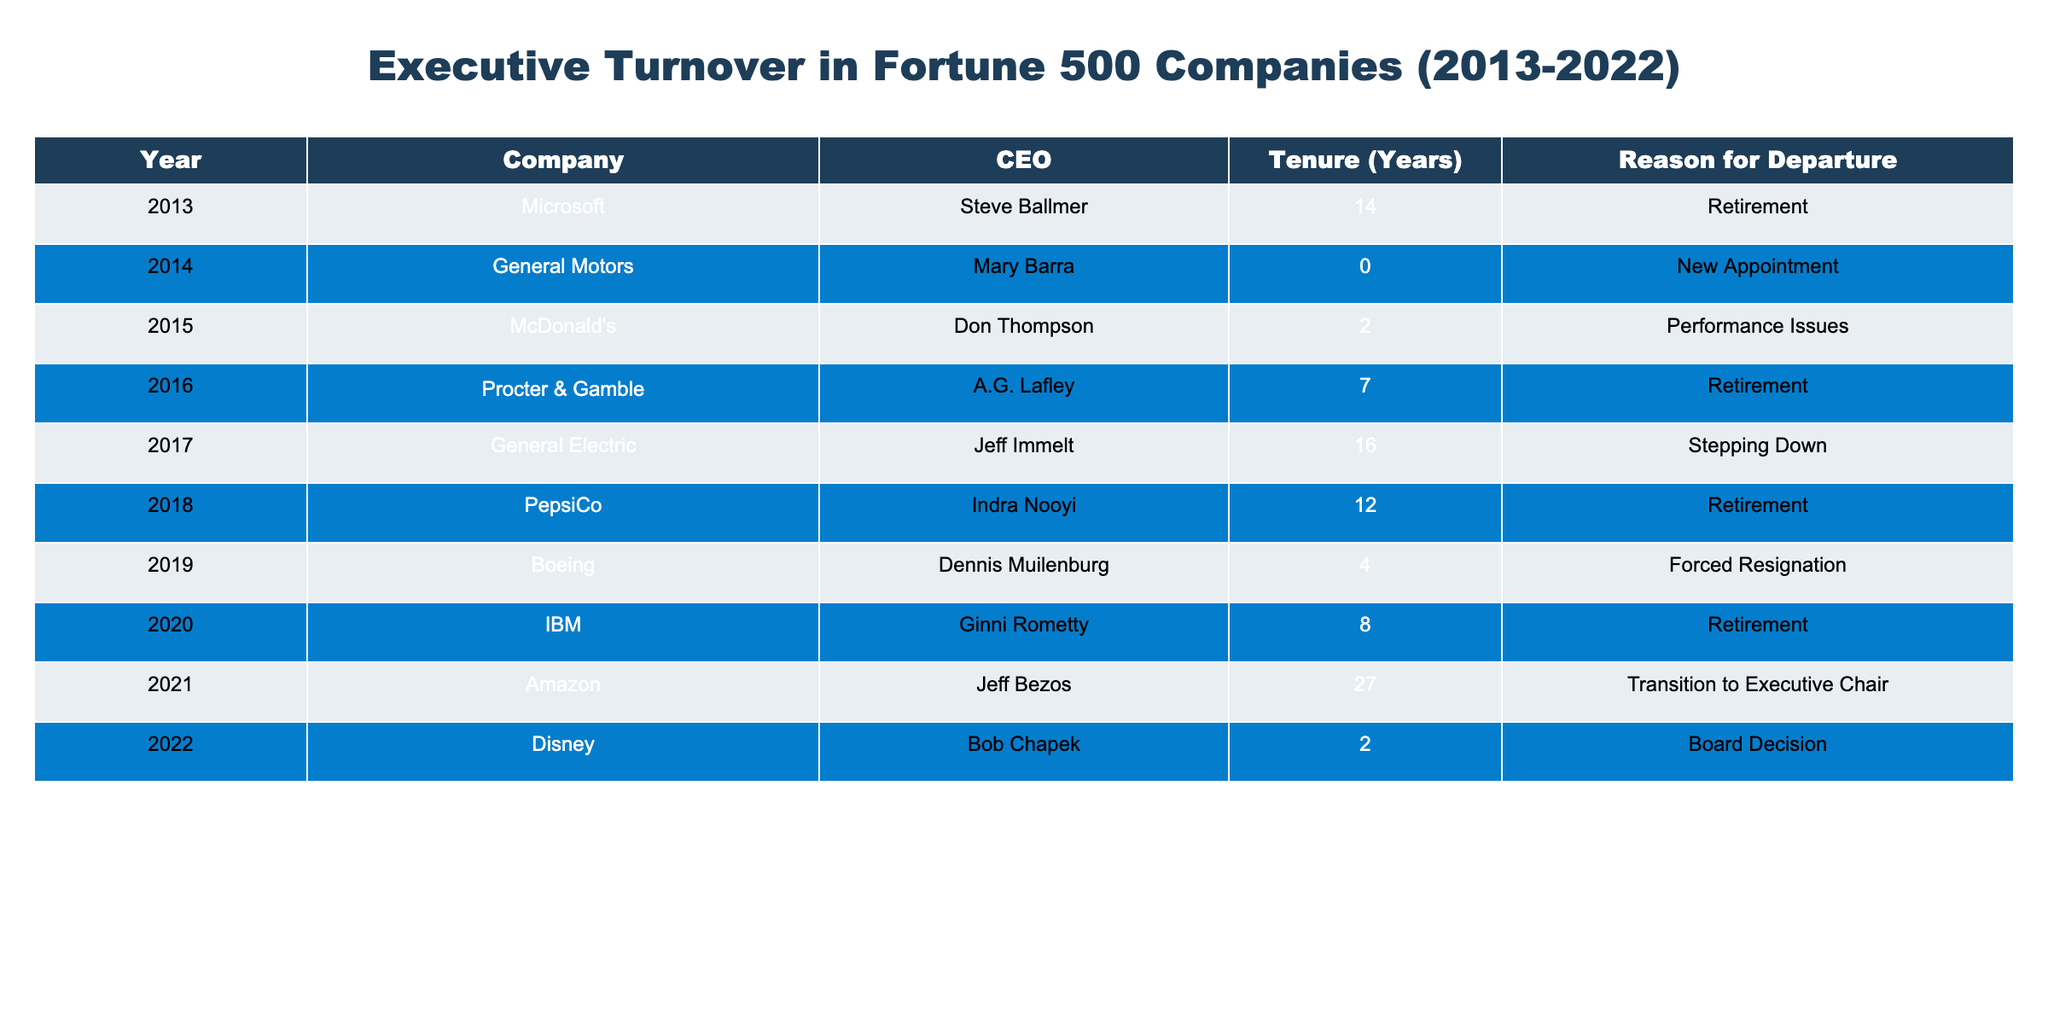What year did Steve Ballmer retire from Microsoft? According to the table, Steve Ballmer retired in 2013.
Answer: 2013 How long did Indra Nooyi serve as CEO of PepsiCo? Indra Nooyi served as CEO for 12 years, as indicated in the tenure column.
Answer: 12 years What was the common reason for CEO departures in this table over the years? By reviewing the reasons for departure, "Retirement" appears multiple times, indicating it is a common reason.
Answer: Yes Which company had the longest-serving CEO based on this table? Jeff Bezos served as CEO of Amazon for 27 years, which is the highest tenure listed in the table.
Answer: Amazon What is the average tenure of the CEOs listed in the table? To find the average, sum the tenures (14 + 0 + 2 + 7 + 16 + 12 + 4 + 8 + 27 + 2 = 92) and divide by the number of CEOs (10). Thus, 92 / 10 = 9.2 years.
Answer: 9.2 years Did any CEO leave due to "Performance Issues"? Yes, Don Thompson left McDonald's due to performance issues.
Answer: Yes What is the difference in tenure between the longest-serving and the shortest-serving CEO in this table? The longest-serving CEO, Jeff Bezos, had a tenure of 27 years, while the shortest, Mary Barra, had a tenure of 0 years. The difference is 27 - 0 = 27 years.
Answer: 27 years Which CEO had the shortest tenure before their departure, and what was the reason? Mary Barra had the shortest tenure of 0 years, and the reason for her departure was a new appointment.
Answer: Mary Barra, New Appointment How many CEOs left their position for reasons other than retirement? By checking the reasons, there are 4 instances where the departure reasons are not retirements: New Appointment, Performance Issues, Forced Resignation, and Board Decision.
Answer: 4 CEOs Was there any CEO from the sample who stepped down voluntarily? Jeff Immelt from General Electric is noted to have stepped down, but it's important to analyze if this is listed as voluntary; he was stepping down, so he fits the criteria.
Answer: Yes 